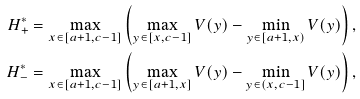Convert formula to latex. <formula><loc_0><loc_0><loc_500><loc_500>H _ { + } ^ { * } & = \max _ { x \in [ a + 1 , c - 1 ] } \left ( \max _ { y \in [ x , c - 1 ] } V ( y ) - \min _ { y \in [ a + 1 , x ) } V ( y ) \right ) , \\ H _ { - } ^ { * } & = \max _ { x \in [ a + 1 , c - 1 ] } \left ( \max _ { y \in [ a + 1 , x ] } V ( y ) - \min _ { y \in ( x , c - 1 ] } V ( y ) \right ) ,</formula> 